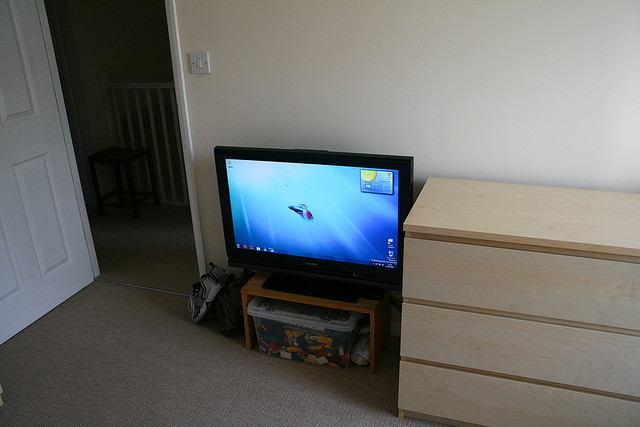Can you list what items are visible around the television? Around the television, various items include a small black DVD player or set-top box located directly underneath the TV, a light wooden drawer cabinet to the right with its contents partially open, revealing some items inside, a children's toy box below the cabinet that appears to contain toys or children's books, and multiple cables connecting to the TV and other devices. 